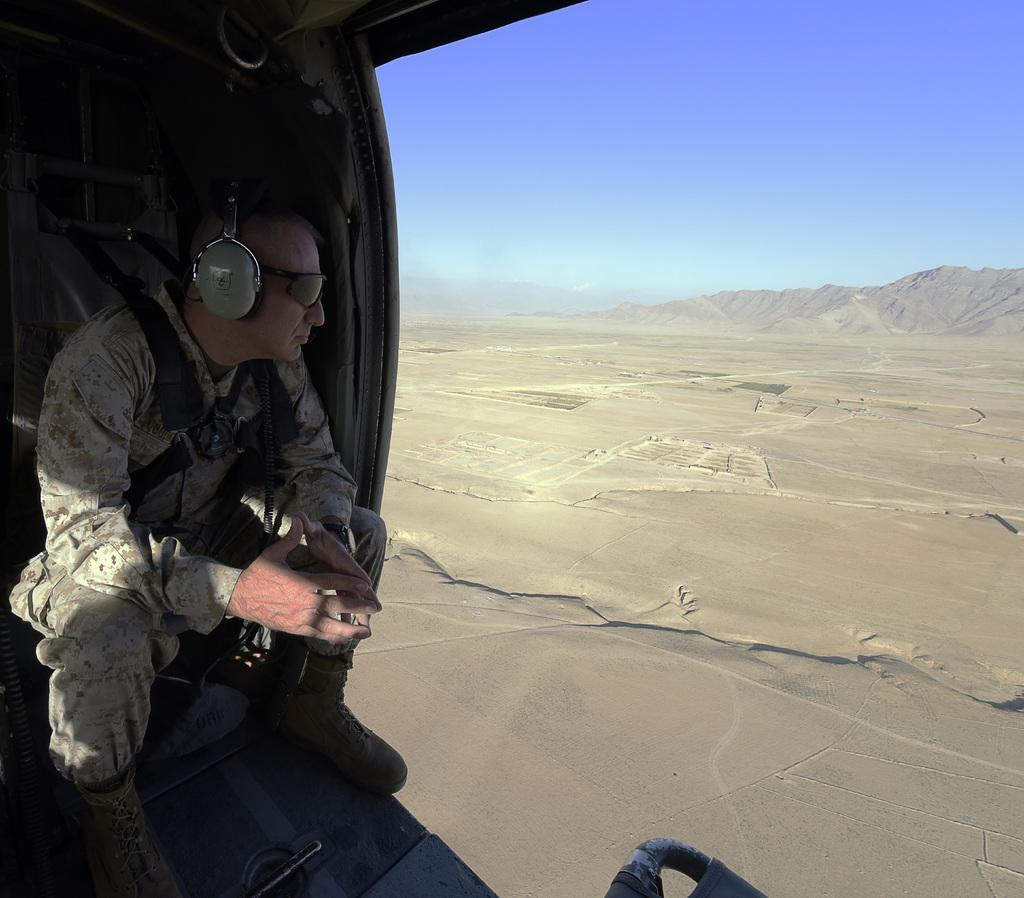What can be seen on the left side of the image? There is a person on the left side of the image, and they are wearing a headset and goggles. What objects are present on the left side of the image? There are objects on the left side of the image, but their specific nature is not mentioned in the facts. What is on the right side of the image? There is sand and hills on the right side of the image. What is visible in the sky in the image? The sky is visible in the image, but no specific details about its appearance are provided. What type of dress is the person wearing in the image? The facts do not mention a dress; the person is wearing a headset and goggles. Is there a meeting taking place in the image? There is no information in the facts to suggest that a meeting is taking place in the image. 